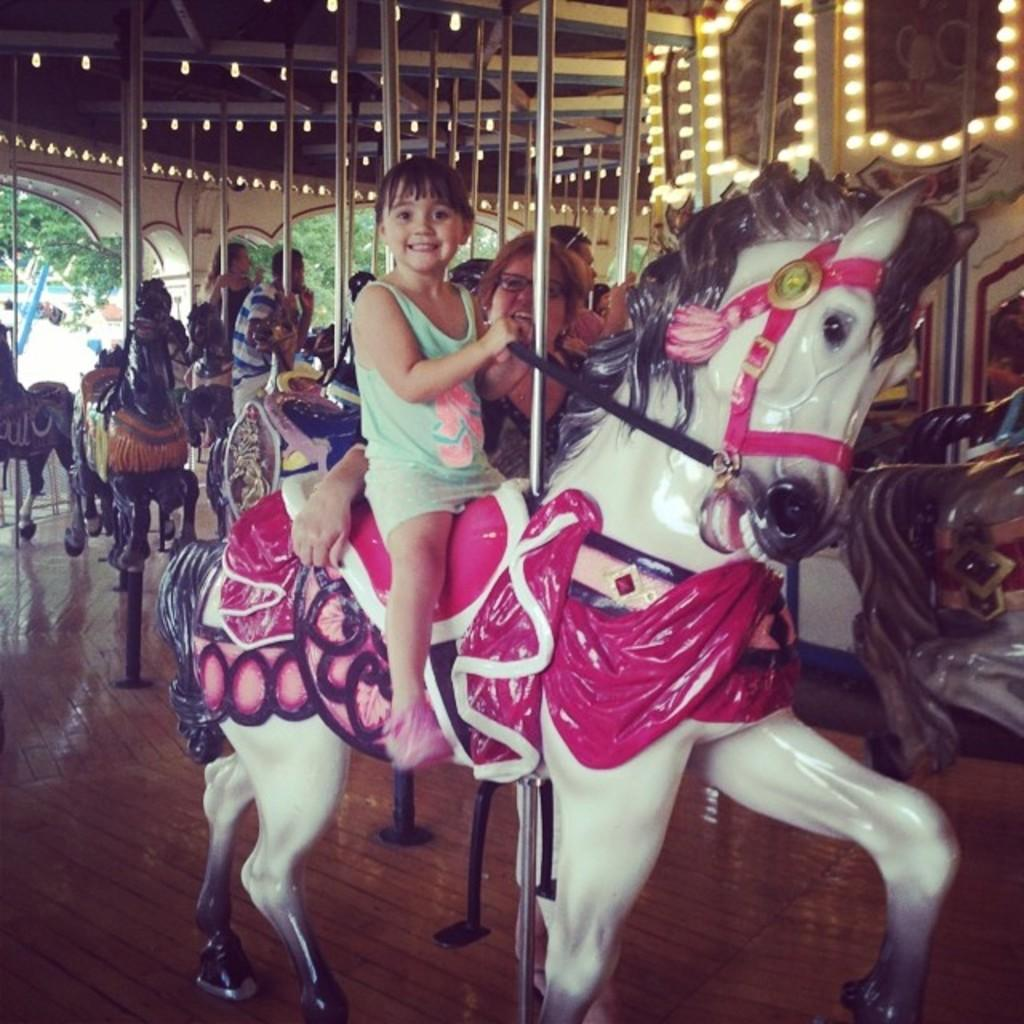Who is present in the image? There are people in the image. What are the people doing in the image? The people are on rides. What type of plants can be seen growing on the fork in the image? There is no fork or plants present in the image. 